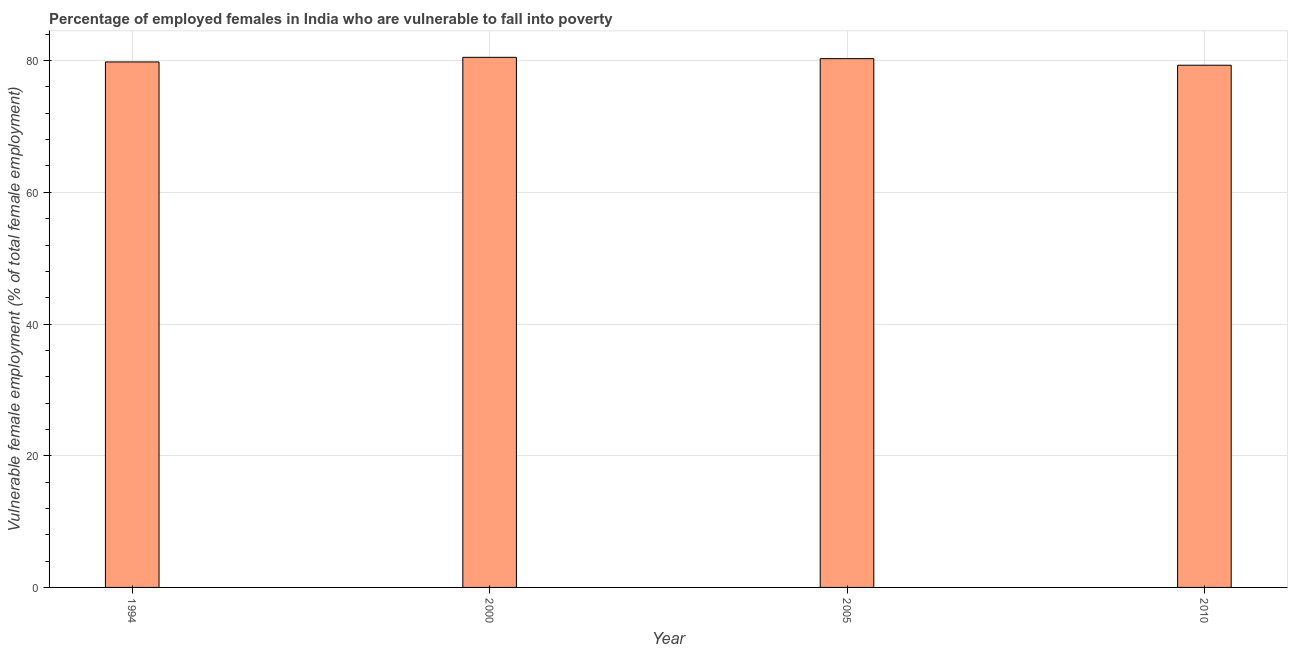Does the graph contain any zero values?
Provide a short and direct response. No. What is the title of the graph?
Your answer should be very brief. Percentage of employed females in India who are vulnerable to fall into poverty. What is the label or title of the Y-axis?
Keep it short and to the point. Vulnerable female employment (% of total female employment). What is the percentage of employed females who are vulnerable to fall into poverty in 2000?
Offer a terse response. 80.5. Across all years, what is the maximum percentage of employed females who are vulnerable to fall into poverty?
Provide a succinct answer. 80.5. Across all years, what is the minimum percentage of employed females who are vulnerable to fall into poverty?
Give a very brief answer. 79.3. In which year was the percentage of employed females who are vulnerable to fall into poverty minimum?
Offer a very short reply. 2010. What is the sum of the percentage of employed females who are vulnerable to fall into poverty?
Provide a succinct answer. 319.9. What is the average percentage of employed females who are vulnerable to fall into poverty per year?
Provide a succinct answer. 79.97. What is the median percentage of employed females who are vulnerable to fall into poverty?
Offer a very short reply. 80.05. Do a majority of the years between 2000 and 2010 (inclusive) have percentage of employed females who are vulnerable to fall into poverty greater than 40 %?
Your answer should be very brief. Yes. What is the ratio of the percentage of employed females who are vulnerable to fall into poverty in 2000 to that in 2010?
Make the answer very short. 1.01. Is the percentage of employed females who are vulnerable to fall into poverty in 1994 less than that in 2010?
Offer a very short reply. No. What is the difference between the highest and the lowest percentage of employed females who are vulnerable to fall into poverty?
Offer a terse response. 1.2. In how many years, is the percentage of employed females who are vulnerable to fall into poverty greater than the average percentage of employed females who are vulnerable to fall into poverty taken over all years?
Provide a short and direct response. 2. What is the difference between two consecutive major ticks on the Y-axis?
Give a very brief answer. 20. What is the Vulnerable female employment (% of total female employment) of 1994?
Provide a succinct answer. 79.8. What is the Vulnerable female employment (% of total female employment) in 2000?
Your response must be concise. 80.5. What is the Vulnerable female employment (% of total female employment) of 2005?
Provide a succinct answer. 80.3. What is the Vulnerable female employment (% of total female employment) in 2010?
Your response must be concise. 79.3. What is the difference between the Vulnerable female employment (% of total female employment) in 1994 and 2000?
Your answer should be very brief. -0.7. What is the difference between the Vulnerable female employment (% of total female employment) in 1994 and 2005?
Keep it short and to the point. -0.5. What is the difference between the Vulnerable female employment (% of total female employment) in 2000 and 2010?
Give a very brief answer. 1.2. What is the ratio of the Vulnerable female employment (% of total female employment) in 1994 to that in 2010?
Provide a short and direct response. 1.01. What is the ratio of the Vulnerable female employment (% of total female employment) in 2005 to that in 2010?
Provide a short and direct response. 1.01. 